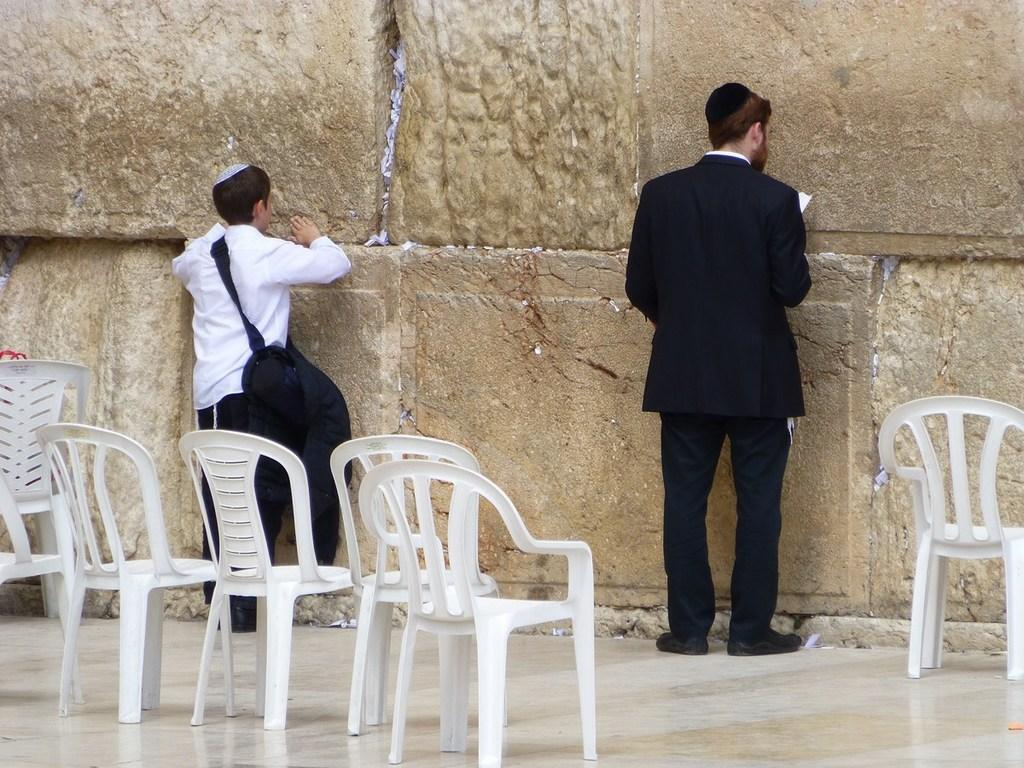Who are the people in the image? There is a man and a boy in the image. What is the man doing in the image? The man is facing a wall and holding a paper. What is the boy carrying in the image? The boy is carrying a bag. What can be seen on the floor in the background of the image? There are chairs on the floor in the background. What type of hook is the man using to climb the wall in the image? There is no hook present in the image, and the man is not climbing the wall. 